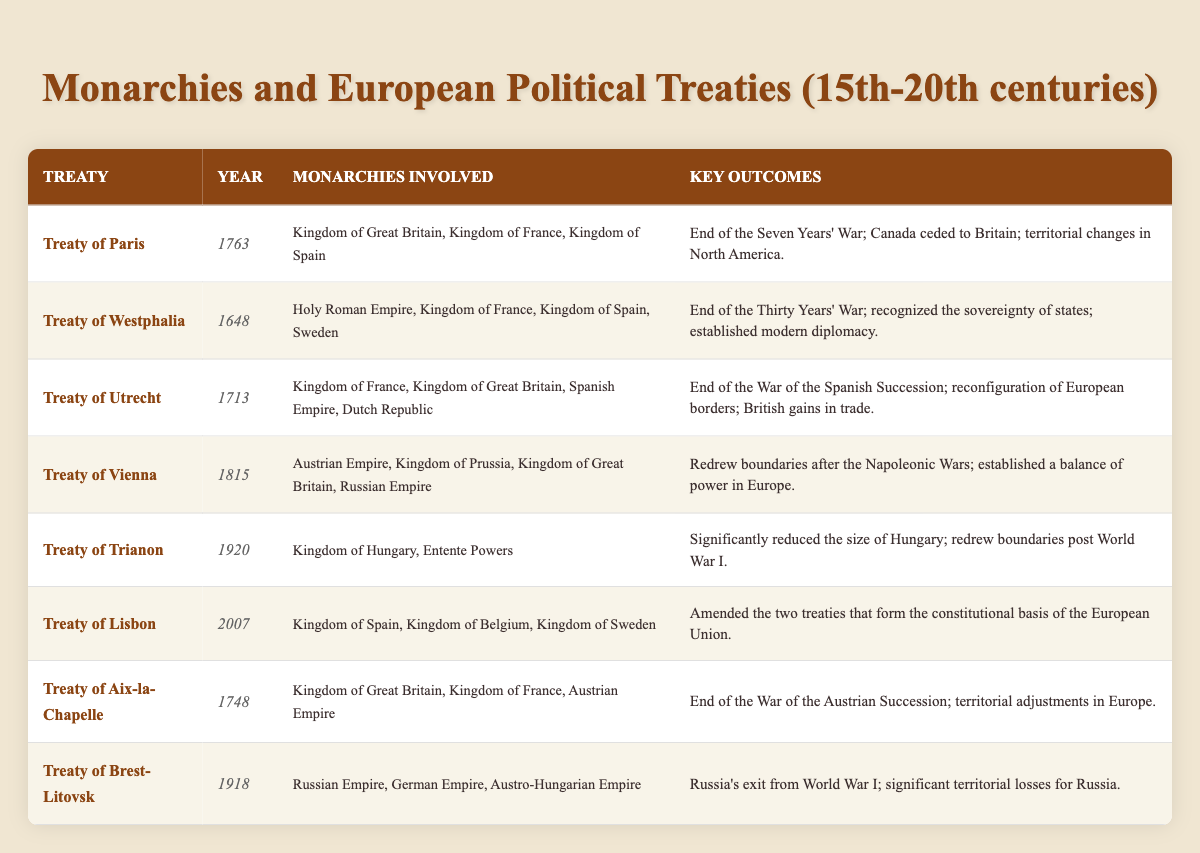What year was the Treaty of Westphalia signed? The table lists the Treaty of Westphalia under the "Year" column, which shows it was signed in 1648.
Answer: 1648 Which monarchies were involved in the Treaty of Paris? By examining the "Monarchies Involved" column for the Treaty of Paris, we can identify the Kingdom of Great Britain, Kingdom of France, and Kingdom of Spain as the involved monarchies.
Answer: Kingdom of Great Britain, Kingdom of France, Kingdom of Spain What were the key outcomes of the Treaty of Vienna? The key outcomes can be found in the "Key Outcomes" column for the Treaty of Vienna, stating it redrew boundaries after the Napoleonic Wars and established a balance of power in Europe.
Answer: Redrew boundaries after the Napoleonic Wars; established a balance of power in Europe How many monarchies were involved in the Treaty of Utrecht? We can count the entries in the "Monarchies Involved" column for the Treaty of Utrecht, which lists four entities: Kingdom of France, Kingdom of Great Britain, Spanish Empire, and Dutch Republic.
Answer: 4 Was the Treaty of Trianon signed before or after World War I? The table shows that the Treaty of Trianon was signed in 1920, which is after World War I ended in 1918.
Answer: After Which treaty resulted in significant territorial losses for Russia? Looking at the "Key Outcomes" column, the Treaty of Brest-Litovsk indicates it resulted in significant territorial losses for Russia, denoting it as the treaty in question.
Answer: Treaty of Brest-Litovsk Identify the treaty that ended the War of the Spanish Succession. From the "Key Outcomes" under the Treaty of Utrecht, it is stated that this treaty ended the War of the Spanish Succession.
Answer: Treaty of Utrecht Between which years was the Treaty of Aix-la-Chapelle signed? The treaty was signed in 1748, as stated in the "Year" column; thus, it represents a single year, not a range.
Answer: 1748 What is the relationship between the year of the Treaty of Lisbon and its constitutional amendments? The Treaty of Lisbon was signed in 2007, as seen in the table, and its key outcomes involve amending treaties that form the constitutional basis of the European Union, this shows a connection to a more modern context of governance.
Answer: It establishes constitutional amendments in the EU How did the Treaty of Brest-Litovsk affect Russia's participation in World War I? The "Key Outcomes" for the Treaty of Brest-Litovsk tell us it signified Russia's exit from World War I, which highlights the direct impact of the treaty on Russia's involvement in the war.
Answer: It marked Russia's exit from World War I Consider the treaties before the 20th century; how many have a key outcome related to territorial adjustments? By checking the "Key Outcomes" of the treaties prior to 1900, we find that both the Treaty of Utrecht, Treaty of Aix-la-Chapelle, and Treaty of Westphalia mention territorial adjustments or changes, leading us to count these entries.
Answer: 3 